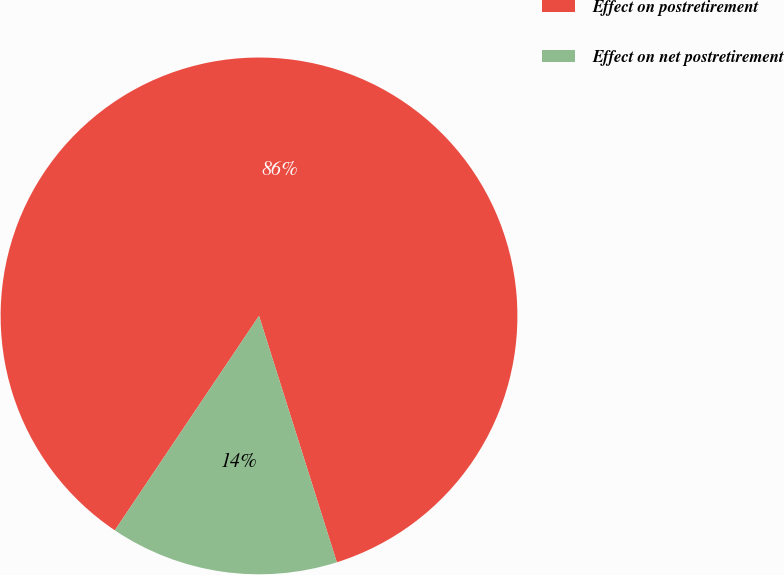Convert chart. <chart><loc_0><loc_0><loc_500><loc_500><pie_chart><fcel>Effect on postretirement<fcel>Effect on net postretirement<nl><fcel>85.71%<fcel>14.29%<nl></chart> 